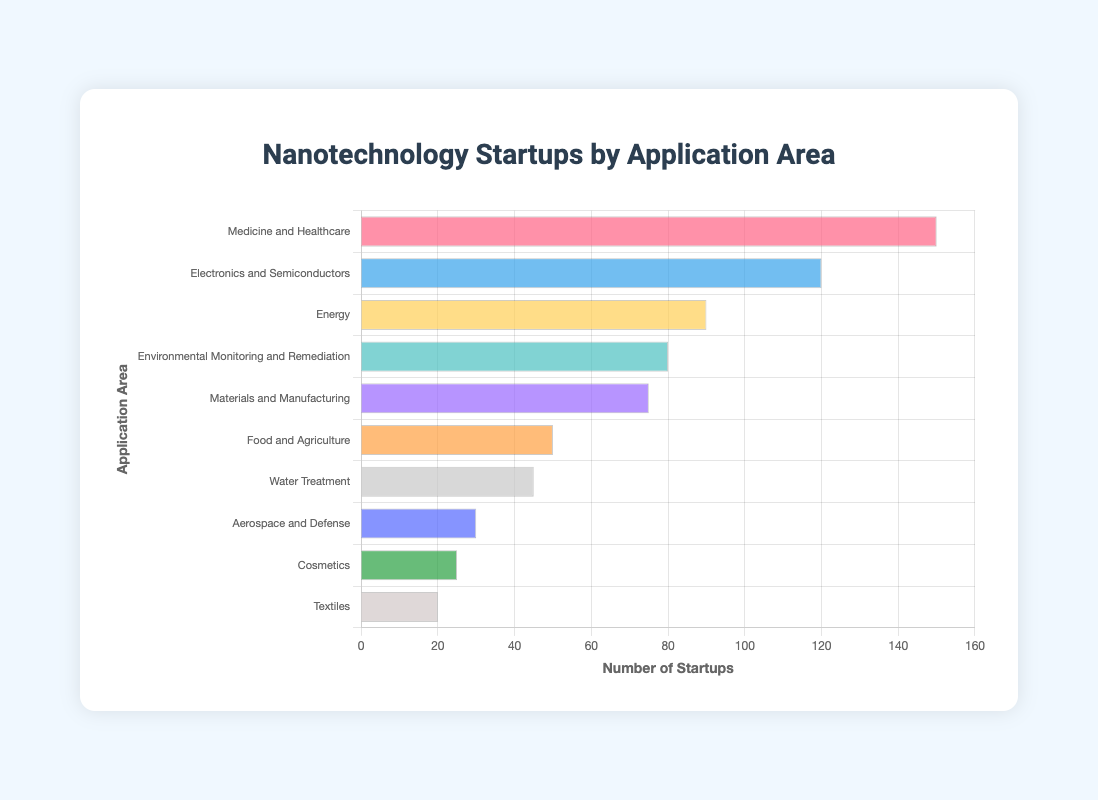Which application area has the highest number of nanotechnology startups? Medicine and Healthcare has the highest number of startups at 150. This can be determined by observing which bar is the longest.
Answer: Medicine and Healthcare Which application area has exactly half the number of startups as Electronics and Semiconductors? Electronics and Semiconductors has 120 startups. The application area with 60 startups would have half, but there is no such category. The closest is Food and Agriculture with 50.
Answer: None What is the total number of nanotechnology startups in the top three application areas? The top three application areas are Medicine and Healthcare (150), Electronics and Semiconductors (120), and Energy (90). Summing these gives 150 + 120 + 90 = 360.
Answer: 360 How many more startups are there in Medicine and Healthcare compared to Environmental Monitoring and Remediation? Medicine and Healthcare has 150 startups, and Environmental Monitoring and Remediation has 80 startups. The difference is 150 - 80 = 70.
Answer: 70 Which application area ranks fifth in terms of the number of startups? From the bar chart, the fifth-ranked application area in terms of the number of startups is Materials and Manufacturing with 75 startups.
Answer: Materials and Manufacturing Are there any application areas with fewer than 30 startups? The application areas with fewer than 30 startups are Aerospace and Defense (30), Cosmetics (25), and Textiles (20).
Answer: Yes How many startups are there on average across all application areas? There are 10 application areas, and the total number of startups is 150 + 120 + 90 + 80 + 75 + 50 + 45 + 30 + 25 + 20 = 685. The average is 685 / 10 = 68.5.
Answer: 68.5 Which application area has the closest number of startups to the mean number of startups across all categories? The mean number of startups is 68.5. Materials and Manufacturing has 75 startups, which is closest to 68.5.
Answer: Materials and Manufacturing What is the combined total number of startups for the application areas with fewer than 50 startups each? The application areas with fewer than 50 startups each include Food and Agriculture (50), Water Treatment (45), Aerospace and Defense (30), Cosmetics (25), and Textiles (20). The total is 50 + 45 + 30 + 25 + 20 = 170.
Answer: 170 